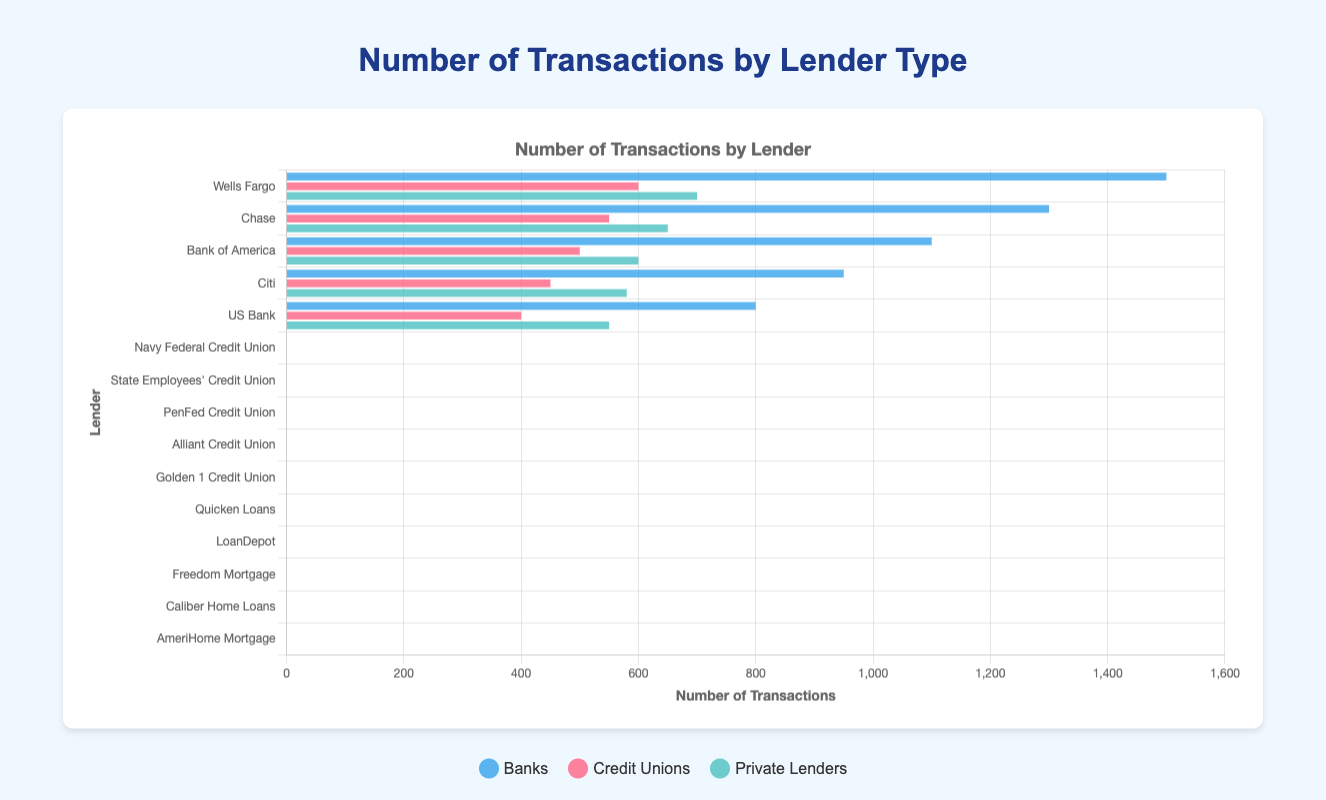Which lender among the banks has handled the most transactions? The figure shows transaction volumes for different banks. Wells Fargo has the highest bar among the banks.
Answer: Wells Fargo What is the total number of transactions handled by Credit Unions? Add the number of transactions for all credit unions: 600 (Navy Federal) + 550 (State Employees') + 500 (PenFed) + 450 (Alliant) + 400 (Golden 1) = 2500
Answer: 2500 Which Credit Union has more transactions: PenFed Credit Union or Alliant Credit Union? Compare the heights of the bars for PenFed Credit Union (500 transactions) and Alliant Credit Union (450 transactions). PenFed has a higher bar.
Answer: PenFed Credit Union What is the difference in transactions between the top bank and the top private lender? Wells Fargo (1500) is the top bank and Quicken Loans (700) is the top private lender. The difference is 1500 - 700 = 800.
Answer: 800 Which lender type uses blue bars in the chart? The legend indicates that banks are represented by blue bars.
Answer: Banks What is the average number of transactions for the banks displayed? Sum the transactions of the banks: 1500 (Wells Fargo) + 1300 (Chase) + 1100 (Bank of America) + 950 (Citi) + 800 (US Bank) = 5650. Divide by the number of banks, 5650 / 5 = 1130.
Answer: 1130 Are there more transactions handled by Private Lenders or Credit Unions? Calculate the total for private lenders: 700 + 650 + 600 + 580 + 550 = 3080. For credit unions: 600 + 550 + 500 + 450 + 400 = 2500. Private lenders have more transactions (3080 vs. 2500).
Answer: Private Lenders What is the sum of transactions for the top two banks? The top two banks are Wells Fargo (1500) and Chase (1300). Sum is 1500 + 1300 = 2800.
Answer: 2800 